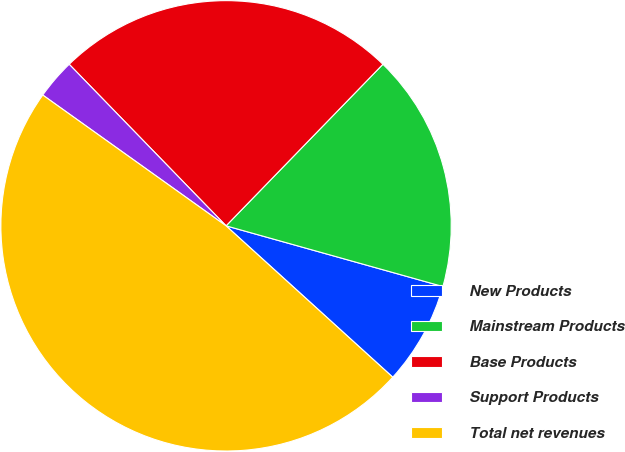Convert chart. <chart><loc_0><loc_0><loc_500><loc_500><pie_chart><fcel>New Products<fcel>Mainstream Products<fcel>Base Products<fcel>Support Products<fcel>Total net revenues<nl><fcel>7.39%<fcel>17.08%<fcel>24.53%<fcel>2.87%<fcel>48.13%<nl></chart> 